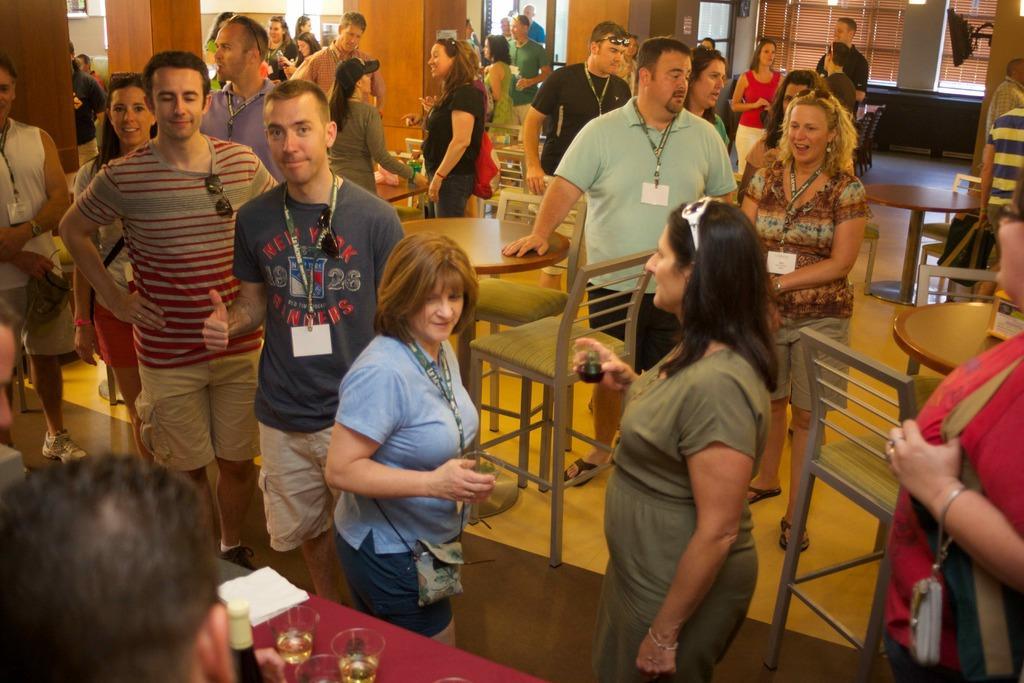Could you give a brief overview of what you see in this image? This picture describes about group of people, beside to them we can see few glasses, bottle and other things on the tables, and also we can see few chairs, monitor and spectacles. 